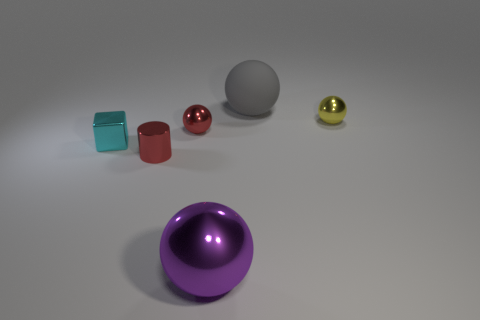Subtract 1 balls. How many balls are left? 3 Add 1 brown matte objects. How many objects exist? 7 Subtract all blocks. How many objects are left? 5 Subtract 1 yellow balls. How many objects are left? 5 Subtract all metal balls. Subtract all tiny metallic cylinders. How many objects are left? 2 Add 2 big purple metal things. How many big purple metal things are left? 3 Add 1 brown metallic things. How many brown metallic things exist? 1 